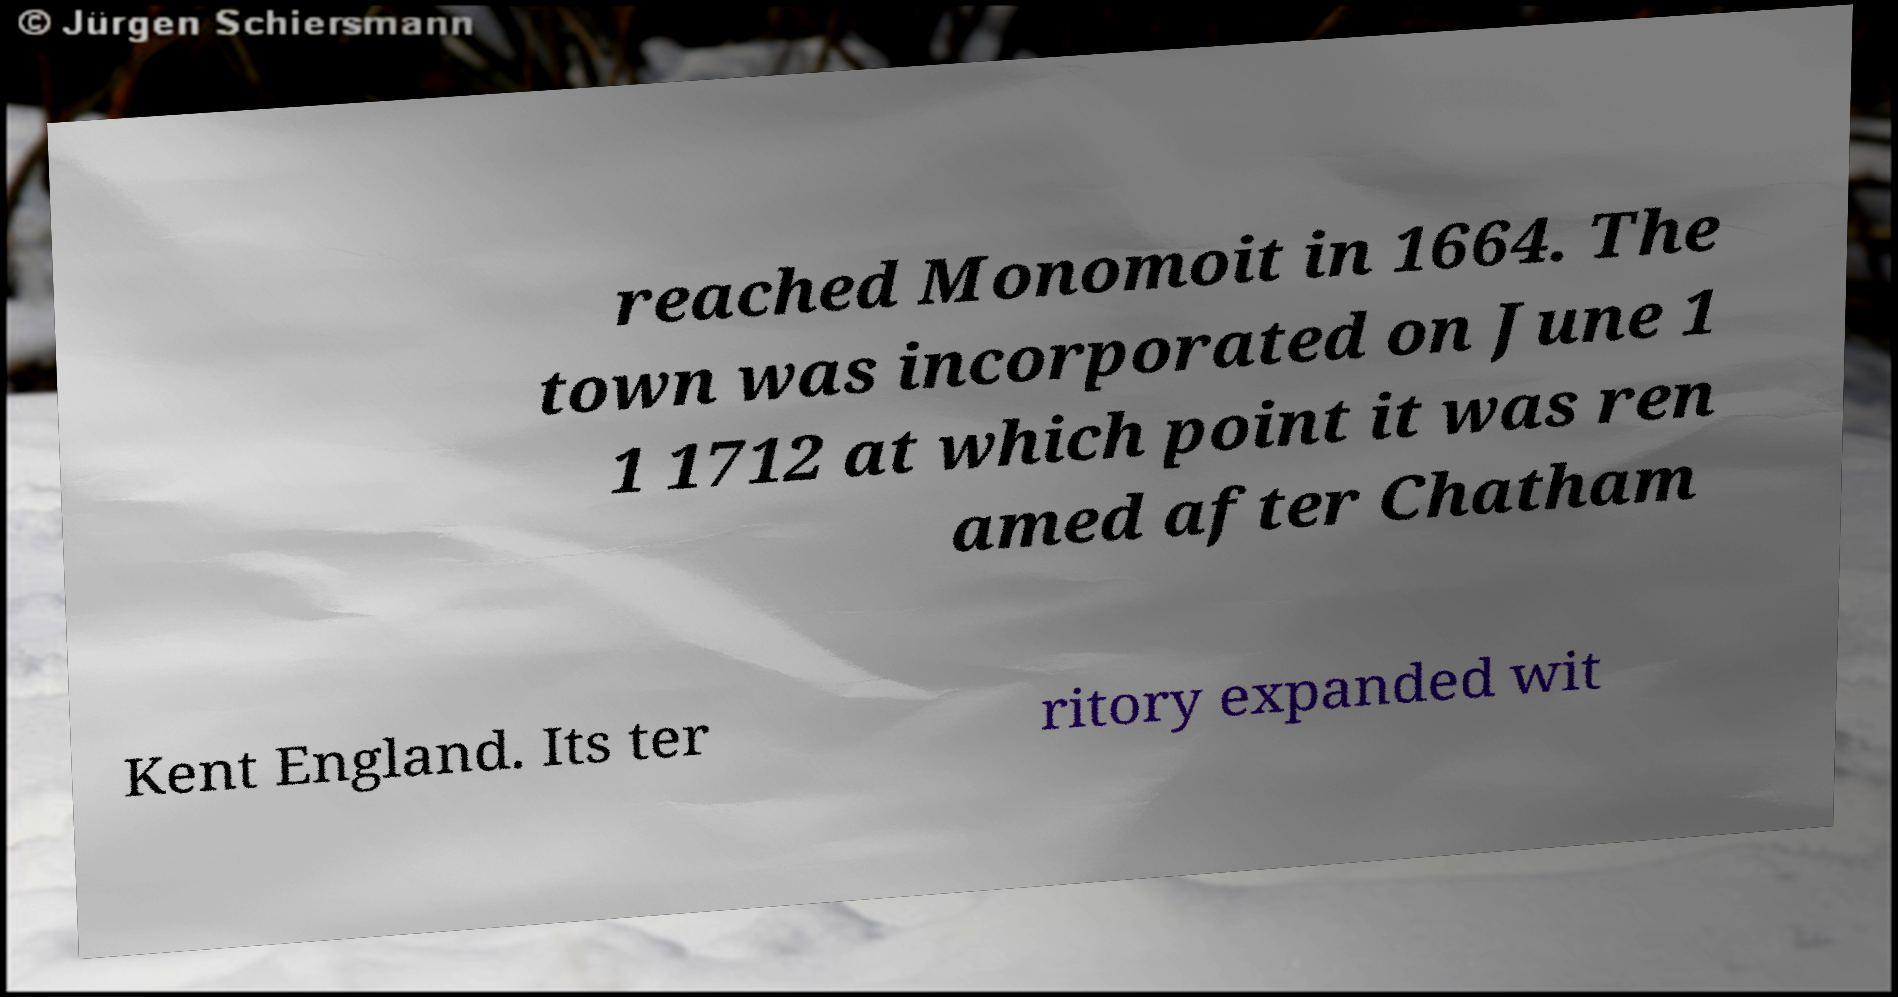There's text embedded in this image that I need extracted. Can you transcribe it verbatim? reached Monomoit in 1664. The town was incorporated on June 1 1 1712 at which point it was ren amed after Chatham Kent England. Its ter ritory expanded wit 